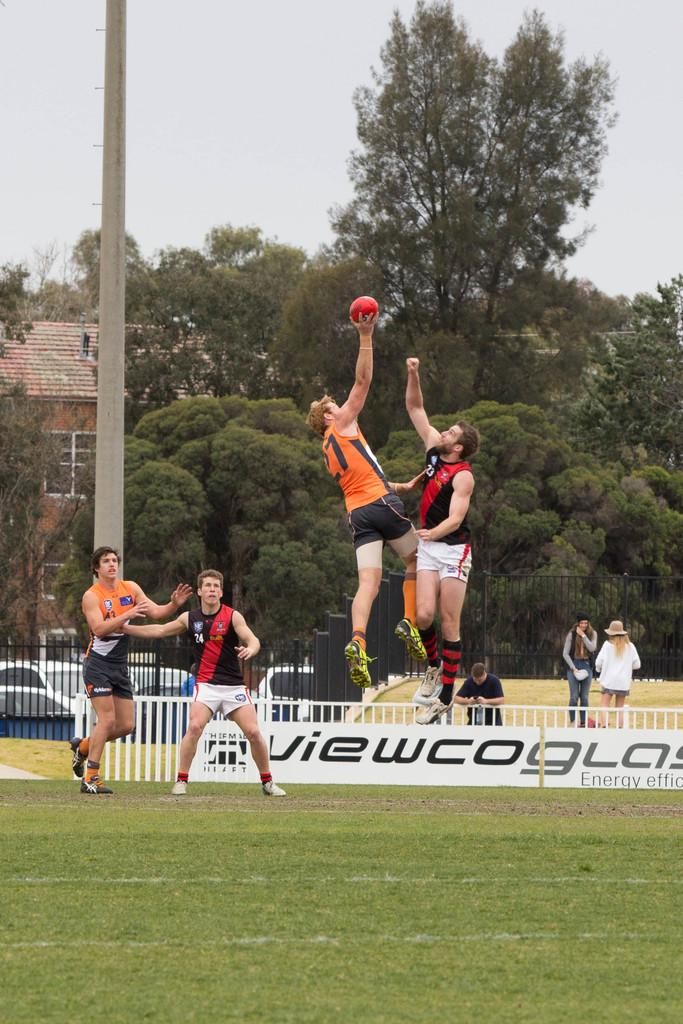<image>
Offer a succinct explanation of the picture presented. Player number 24 has his hand on another player as he keeps his eyes on the ball. 